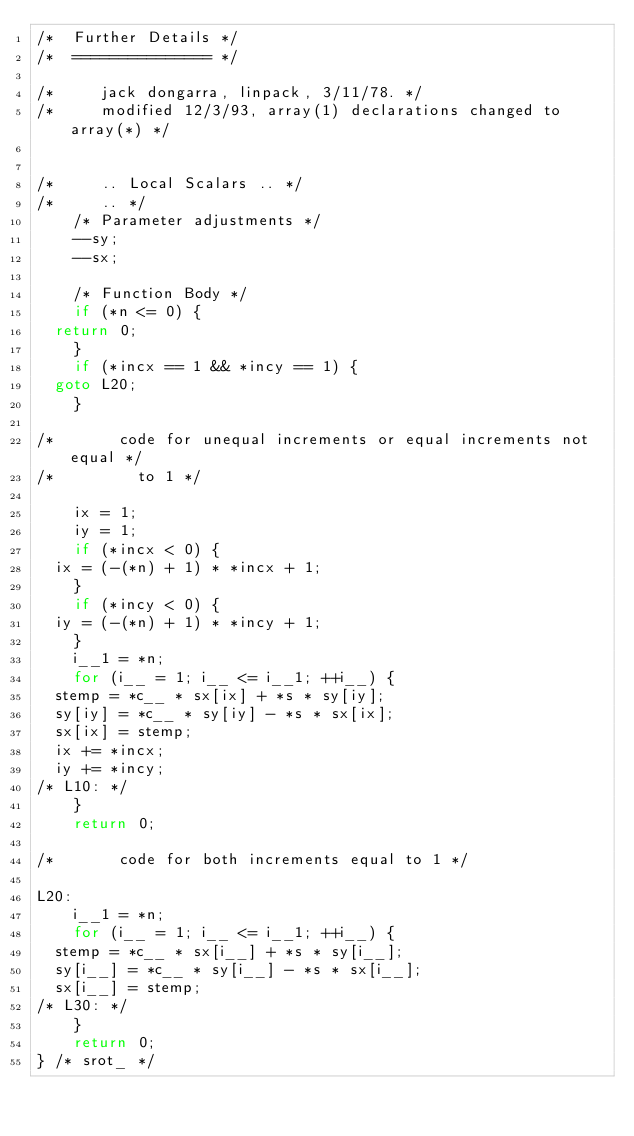Convert code to text. <code><loc_0><loc_0><loc_500><loc_500><_C_>/*  Further Details */
/*  =============== */

/*     jack dongarra, linpack, 3/11/78. */
/*     modified 12/3/93, array(1) declarations changed to array(*) */


/*     .. Local Scalars .. */
/*     .. */
    /* Parameter adjustments */
    --sy;
    --sx;

    /* Function Body */
    if (*n <= 0) {
	return 0;
    }
    if (*incx == 1 && *incy == 1) {
	goto L20;
    }

/*       code for unequal increments or equal increments not equal */
/*         to 1 */

    ix = 1;
    iy = 1;
    if (*incx < 0) {
	ix = (-(*n) + 1) * *incx + 1;
    }
    if (*incy < 0) {
	iy = (-(*n) + 1) * *incy + 1;
    }
    i__1 = *n;
    for (i__ = 1; i__ <= i__1; ++i__) {
	stemp = *c__ * sx[ix] + *s * sy[iy];
	sy[iy] = *c__ * sy[iy] - *s * sx[ix];
	sx[ix] = stemp;
	ix += *incx;
	iy += *incy;
/* L10: */
    }
    return 0;

/*       code for both increments equal to 1 */

L20:
    i__1 = *n;
    for (i__ = 1; i__ <= i__1; ++i__) {
	stemp = *c__ * sx[i__] + *s * sy[i__];
	sy[i__] = *c__ * sy[i__] - *s * sx[i__];
	sx[i__] = stemp;
/* L30: */
    }
    return 0;
} /* srot_ */
</code> 